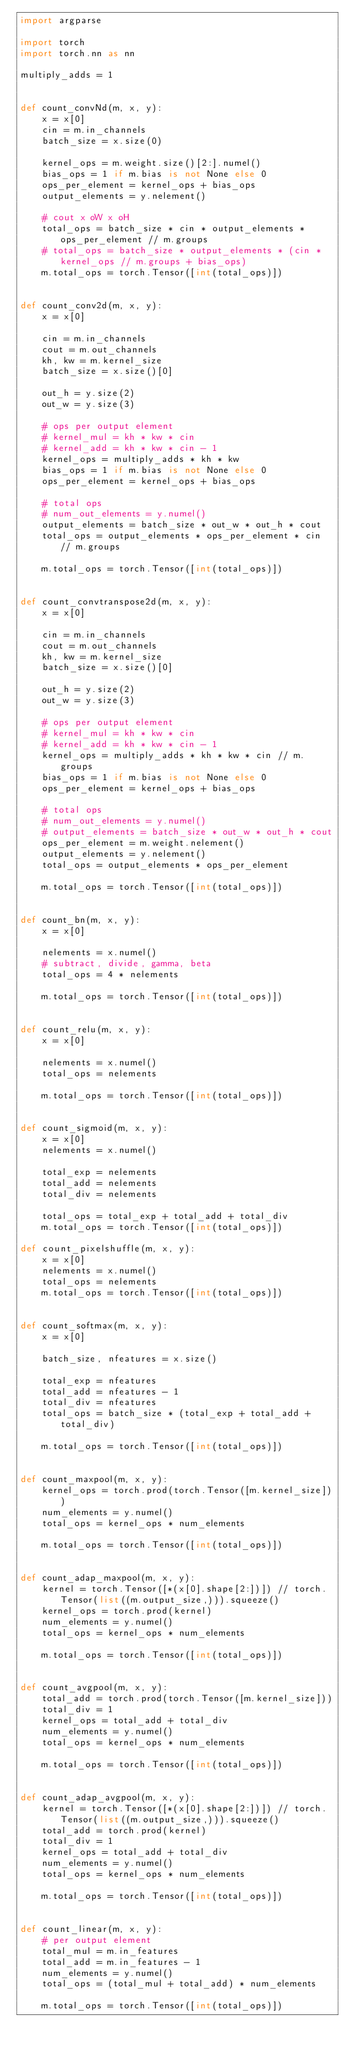<code> <loc_0><loc_0><loc_500><loc_500><_Python_>import argparse

import torch
import torch.nn as nn

multiply_adds = 1


def count_convNd(m, x, y):
    x = x[0]
    cin = m.in_channels
    batch_size = x.size(0)

    kernel_ops = m.weight.size()[2:].numel()
    bias_ops = 1 if m.bias is not None else 0
    ops_per_element = kernel_ops + bias_ops
    output_elements = y.nelement()

    # cout x oW x oH
    total_ops = batch_size * cin * output_elements * ops_per_element // m.groups
    # total_ops = batch_size * output_elements * (cin * kernel_ops // m.groups + bias_ops)
    m.total_ops = torch.Tensor([int(total_ops)])


def count_conv2d(m, x, y):
    x = x[0]

    cin = m.in_channels
    cout = m.out_channels
    kh, kw = m.kernel_size
    batch_size = x.size()[0]

    out_h = y.size(2)
    out_w = y.size(3)

    # ops per output element
    # kernel_mul = kh * kw * cin
    # kernel_add = kh * kw * cin - 1
    kernel_ops = multiply_adds * kh * kw
    bias_ops = 1 if m.bias is not None else 0
    ops_per_element = kernel_ops + bias_ops

    # total ops
    # num_out_elements = y.numel()
    output_elements = batch_size * out_w * out_h * cout
    total_ops = output_elements * ops_per_element * cin // m.groups

    m.total_ops = torch.Tensor([int(total_ops)])


def count_convtranspose2d(m, x, y):
    x = x[0]

    cin = m.in_channels
    cout = m.out_channels
    kh, kw = m.kernel_size
    batch_size = x.size()[0]

    out_h = y.size(2)
    out_w = y.size(3)

    # ops per output element
    # kernel_mul = kh * kw * cin
    # kernel_add = kh * kw * cin - 1
    kernel_ops = multiply_adds * kh * kw * cin // m.groups
    bias_ops = 1 if m.bias is not None else 0
    ops_per_element = kernel_ops + bias_ops

    # total ops
    # num_out_elements = y.numel()
    # output_elements = batch_size * out_w * out_h * cout
    ops_per_element = m.weight.nelement()
    output_elements = y.nelement()
    total_ops = output_elements * ops_per_element

    m.total_ops = torch.Tensor([int(total_ops)])


def count_bn(m, x, y):
    x = x[0]

    nelements = x.numel()
    # subtract, divide, gamma, beta
    total_ops = 4 * nelements

    m.total_ops = torch.Tensor([int(total_ops)])


def count_relu(m, x, y):
    x = x[0]

    nelements = x.numel()
    total_ops = nelements

    m.total_ops = torch.Tensor([int(total_ops)])


def count_sigmoid(m, x, y):
    x = x[0]
    nelements = x.numel()

    total_exp = nelements
    total_add = nelements
    total_div = nelements

    total_ops = total_exp + total_add + total_div
    m.total_ops = torch.Tensor([int(total_ops)])

def count_pixelshuffle(m, x, y):
    x = x[0]
    nelements = x.numel()
    total_ops = nelements
    m.total_ops = torch.Tensor([int(total_ops)])


def count_softmax(m, x, y):
    x = x[0]

    batch_size, nfeatures = x.size()

    total_exp = nfeatures
    total_add = nfeatures - 1
    total_div = nfeatures
    total_ops = batch_size * (total_exp + total_add + total_div)

    m.total_ops = torch.Tensor([int(total_ops)])


def count_maxpool(m, x, y):
    kernel_ops = torch.prod(torch.Tensor([m.kernel_size]))
    num_elements = y.numel()
    total_ops = kernel_ops * num_elements

    m.total_ops = torch.Tensor([int(total_ops)])


def count_adap_maxpool(m, x, y):
    kernel = torch.Tensor([*(x[0].shape[2:])]) // torch.Tensor(list((m.output_size,))).squeeze()
    kernel_ops = torch.prod(kernel)
    num_elements = y.numel()
    total_ops = kernel_ops * num_elements

    m.total_ops = torch.Tensor([int(total_ops)])


def count_avgpool(m, x, y):
    total_add = torch.prod(torch.Tensor([m.kernel_size]))
    total_div = 1
    kernel_ops = total_add + total_div
    num_elements = y.numel()
    total_ops = kernel_ops * num_elements

    m.total_ops = torch.Tensor([int(total_ops)])


def count_adap_avgpool(m, x, y):
    kernel = torch.Tensor([*(x[0].shape[2:])]) // torch.Tensor(list((m.output_size,))).squeeze()
    total_add = torch.prod(kernel)
    total_div = 1
    kernel_ops = total_add + total_div
    num_elements = y.numel()
    total_ops = kernel_ops * num_elements

    m.total_ops = torch.Tensor([int(total_ops)])


def count_linear(m, x, y):
    # per output element
    total_mul = m.in_features
    total_add = m.in_features - 1
    num_elements = y.numel()
    total_ops = (total_mul + total_add) * num_elements

    m.total_ops = torch.Tensor([int(total_ops)])
</code> 